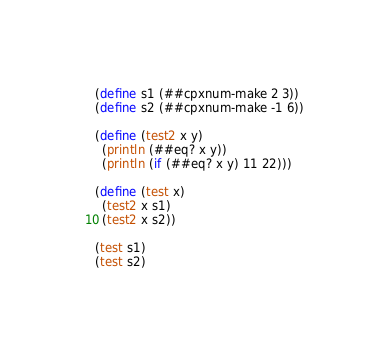<code> <loc_0><loc_0><loc_500><loc_500><_Scheme_>(define s1 (##cpxnum-make 2 3))
(define s2 (##cpxnum-make -1 6))

(define (test2 x y)
  (println (##eq? x y))
  (println (if (##eq? x y) 11 22)))

(define (test x)
  (test2 x s1)
  (test2 x s2))

(test s1)
(test s2)
</code> 